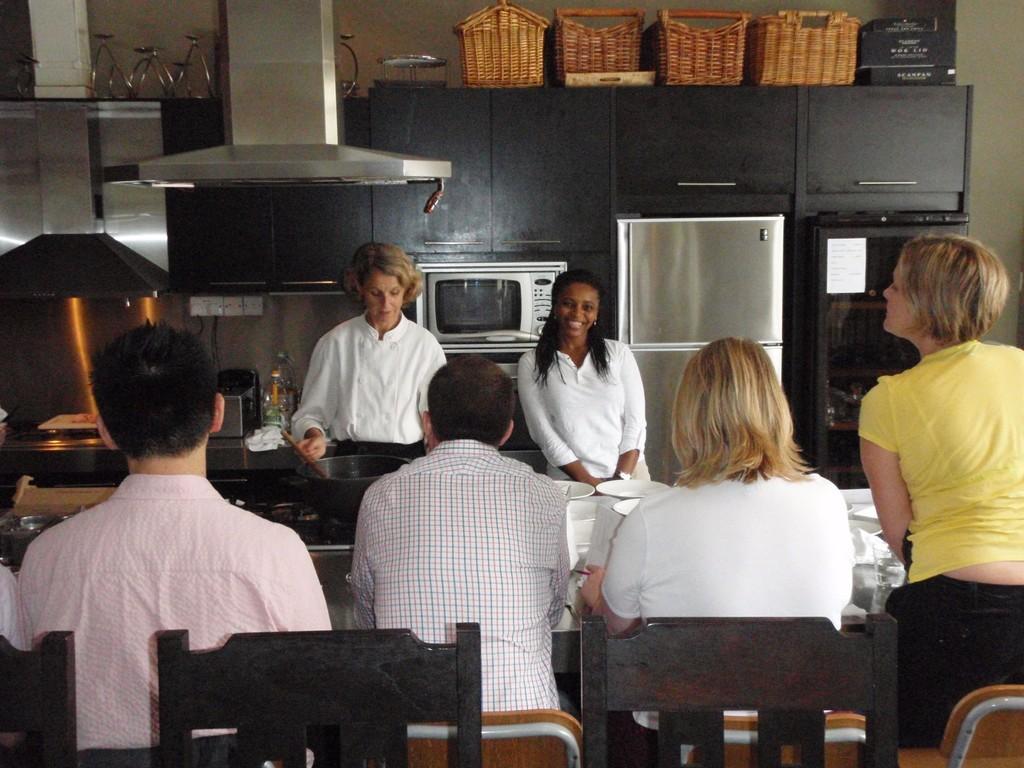Describe this image in one or two sentences. In the image we can see there are people who are sitting on chair and there are two women who are standing in front of them and they are looking at each other. On table there are bowl, plates and woman is cooking in the bowl. On behind there is an oven and refrigerator and on the top there are baskets which are kept. 